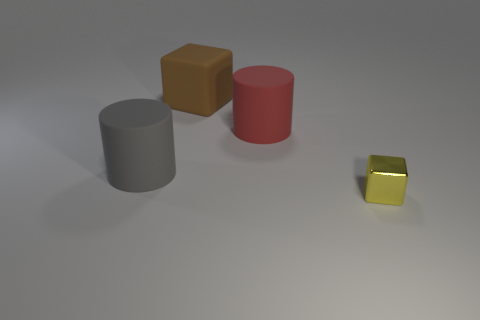Add 1 small gray spheres. How many objects exist? 5 Subtract 0 brown cylinders. How many objects are left? 4 Subtract all tiny things. Subtract all tiny cyan cubes. How many objects are left? 3 Add 3 big matte objects. How many big matte objects are left? 6 Add 2 blue rubber cylinders. How many blue rubber cylinders exist? 2 